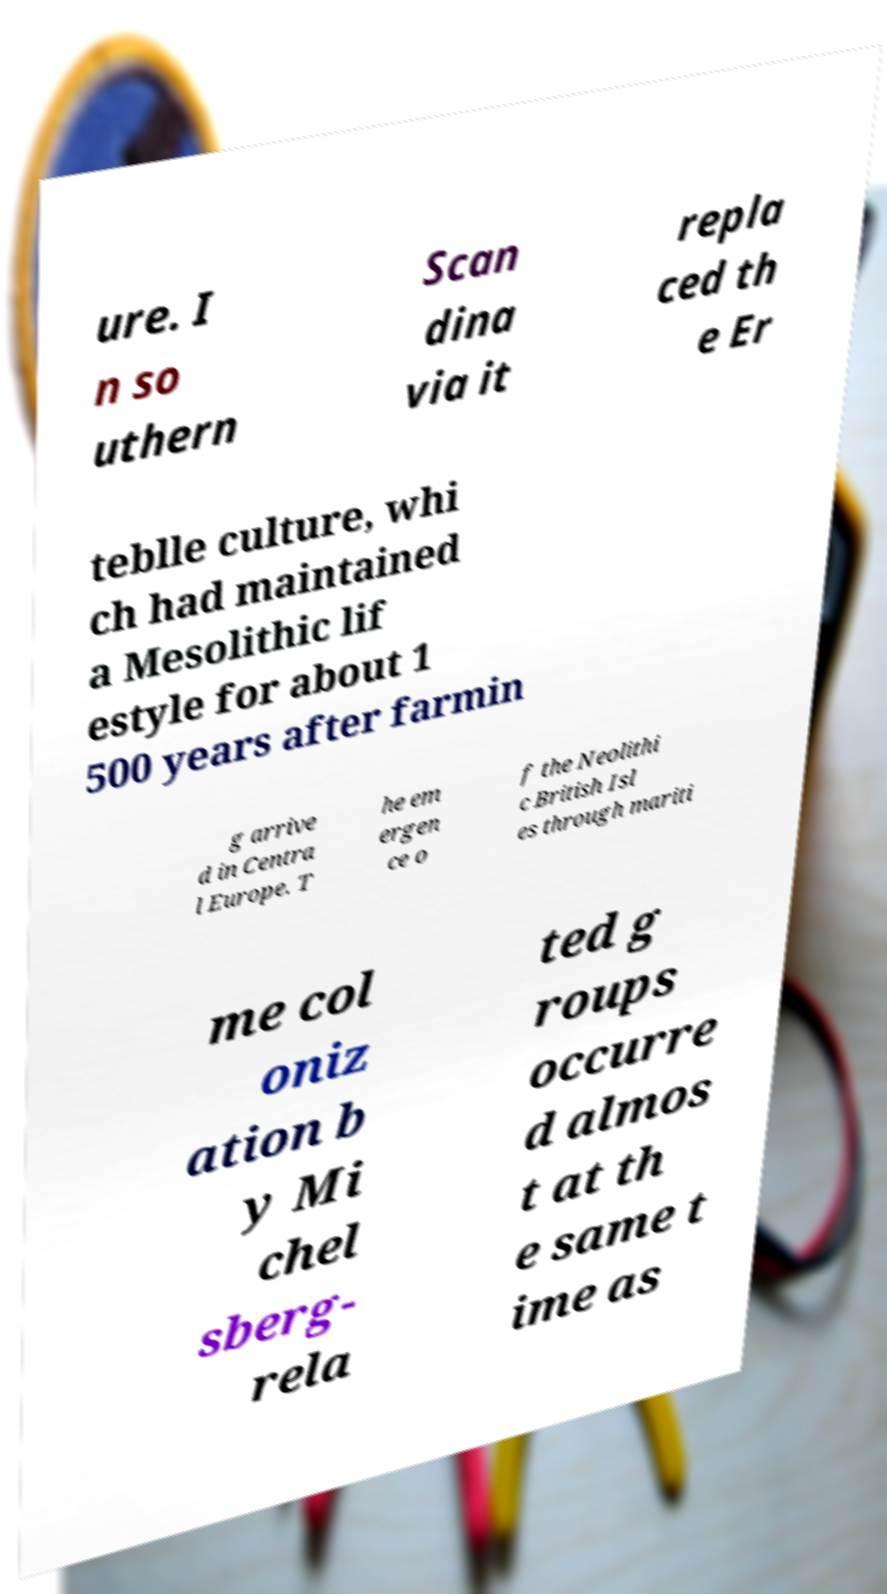Could you assist in decoding the text presented in this image and type it out clearly? ure. I n so uthern Scan dina via it repla ced th e Er teblle culture, whi ch had maintained a Mesolithic lif estyle for about 1 500 years after farmin g arrive d in Centra l Europe. T he em ergen ce o f the Neolithi c British Isl es through mariti me col oniz ation b y Mi chel sberg- rela ted g roups occurre d almos t at th e same t ime as 